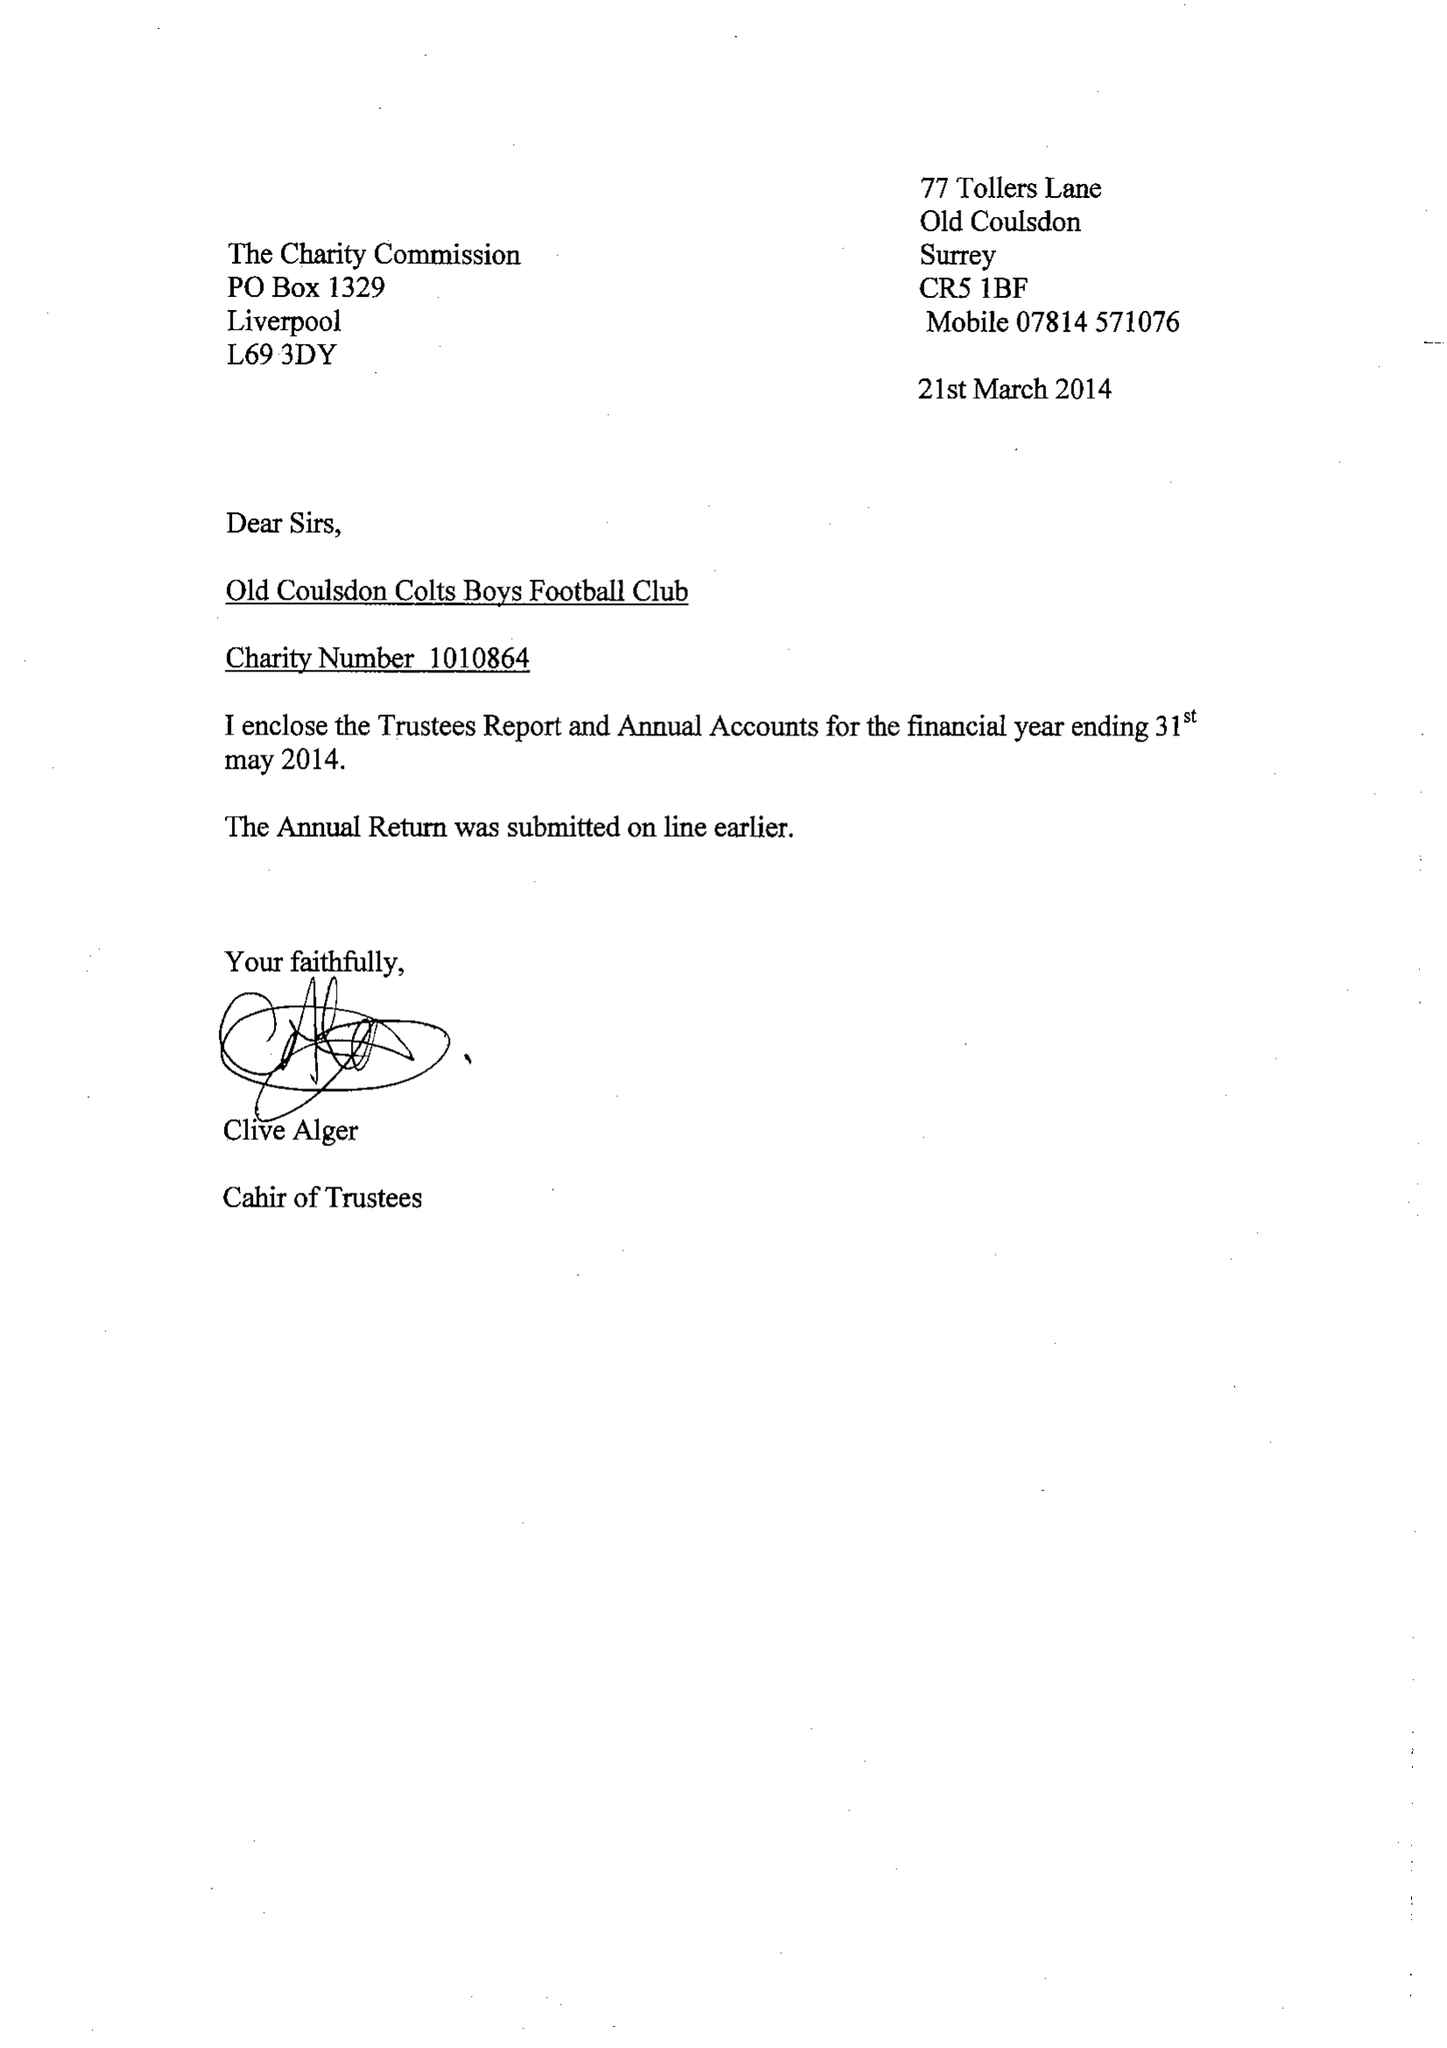What is the value for the address__post_town?
Answer the question using a single word or phrase. COULSDON 